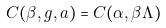Convert formula to latex. <formula><loc_0><loc_0><loc_500><loc_500>C ( \beta , g , a ) = C ( \alpha , \beta \Lambda )</formula> 